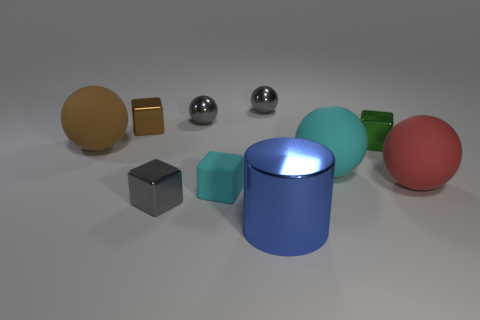Subtract all brown metallic blocks. How many blocks are left? 3 Subtract all cylinders. How many objects are left? 9 Subtract 4 blocks. How many blocks are left? 0 Subtract all gray spheres. Subtract all brown blocks. How many spheres are left? 3 Subtract all red balls. How many gray blocks are left? 1 Subtract all cylinders. Subtract all blue metal things. How many objects are left? 8 Add 5 green metal objects. How many green metal objects are left? 6 Add 8 tiny gray metallic cubes. How many tiny gray metallic cubes exist? 9 Subtract all red balls. How many balls are left? 4 Subtract 1 red balls. How many objects are left? 9 